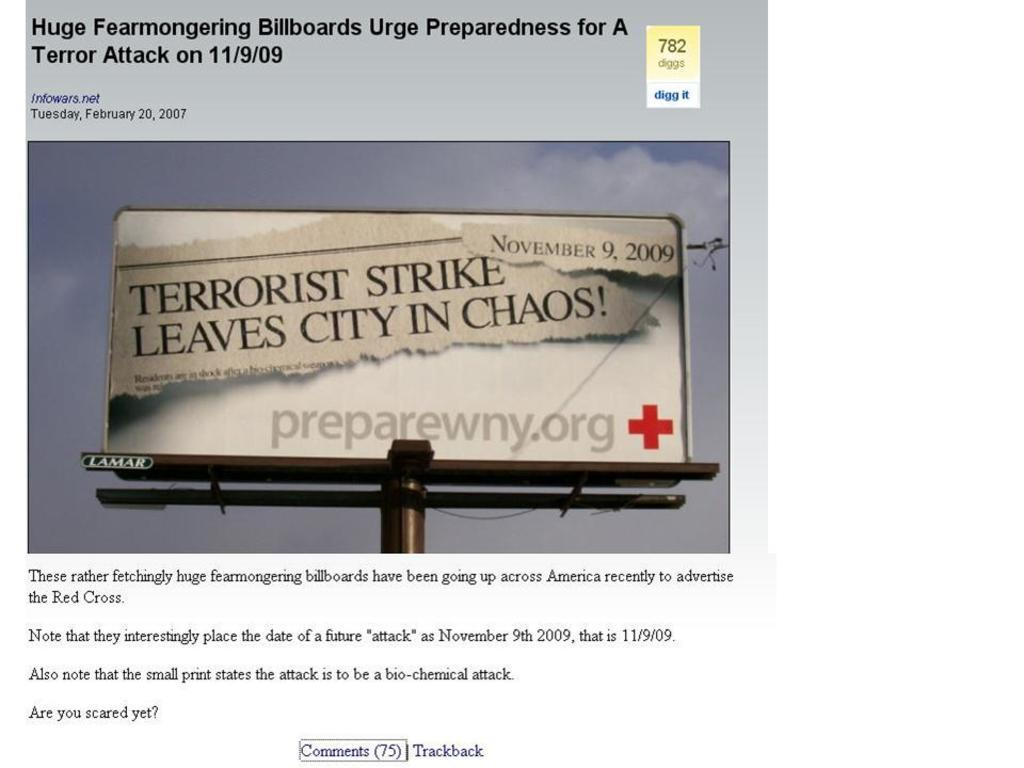Provide a one-sentence caption for the provided image. billboards urge preparedness for a terrorist attack held on 11/9/09. 